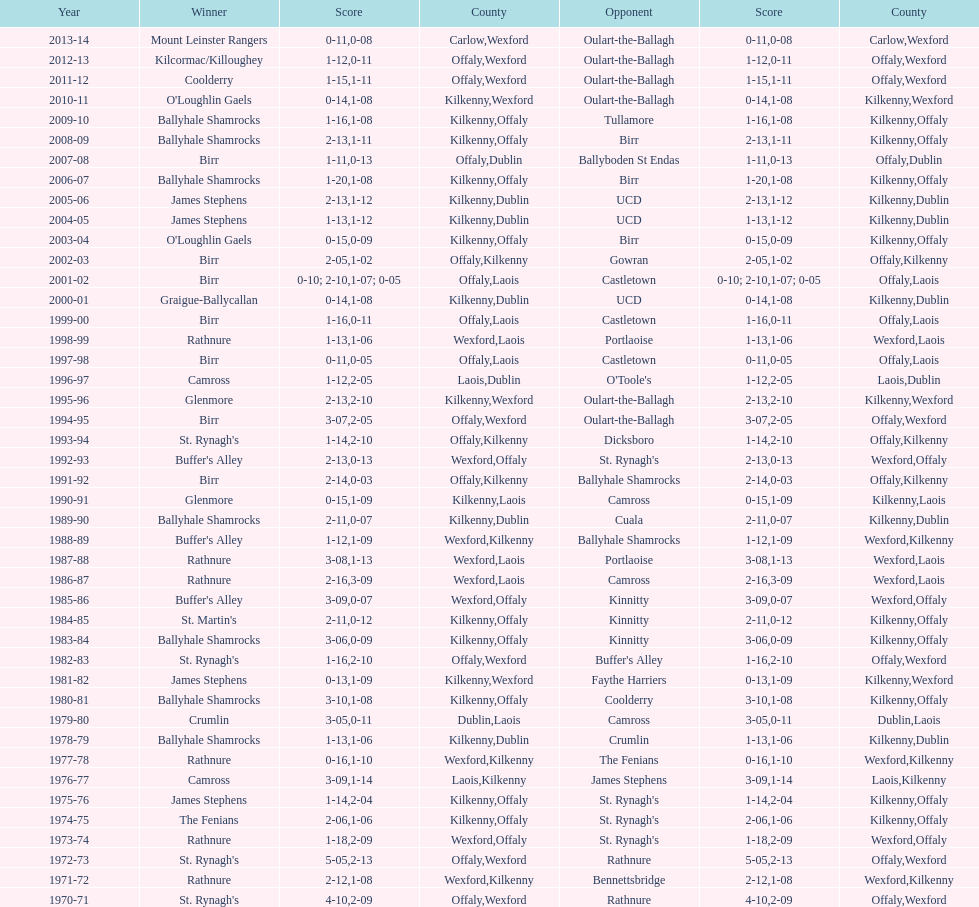Which team won the leinster senior club hurling championships previous to the last time birr won? Ballyhale Shamrocks. 